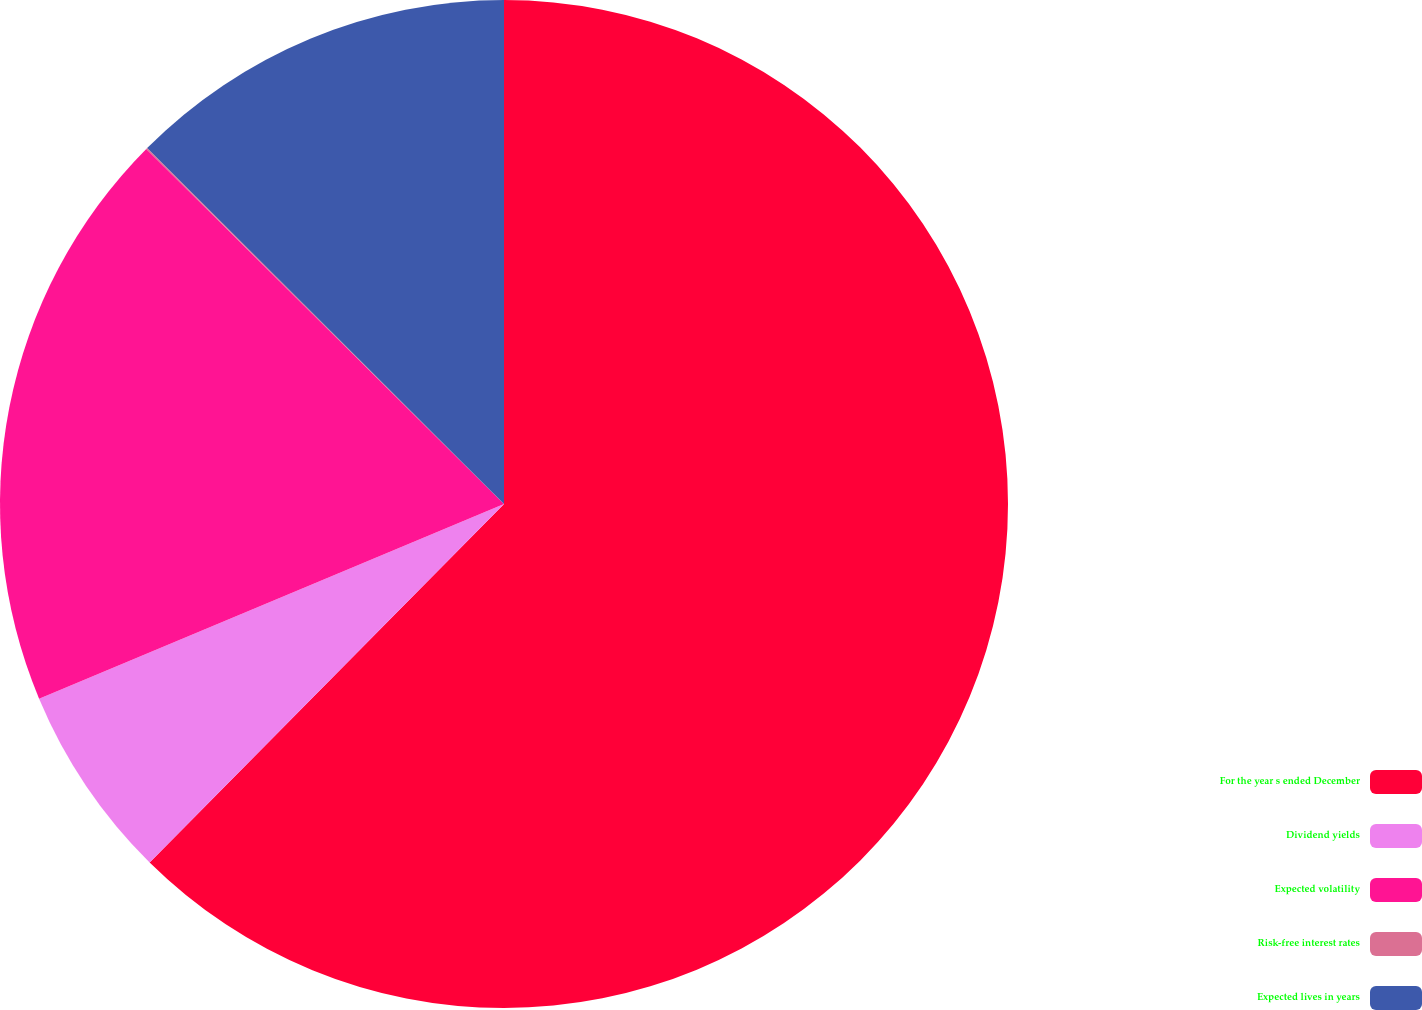<chart> <loc_0><loc_0><loc_500><loc_500><pie_chart><fcel>For the year s ended December<fcel>Dividend yields<fcel>Expected volatility<fcel>Risk-free interest rates<fcel>Expected lives in years<nl><fcel>62.41%<fcel>6.28%<fcel>18.75%<fcel>0.04%<fcel>12.52%<nl></chart> 